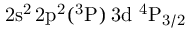Convert formula to latex. <formula><loc_0><loc_0><loc_500><loc_500>2 s ^ { 2 } \, 2 p ^ { 2 } ( ^ { 3 } P ) \, 3 d ^ { 4 } P _ { 3 / 2 }</formula> 